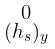<formula> <loc_0><loc_0><loc_500><loc_500>\begin{smallmatrix} 0 \\ ( h _ { s } ) _ { y } \end{smallmatrix}</formula> 